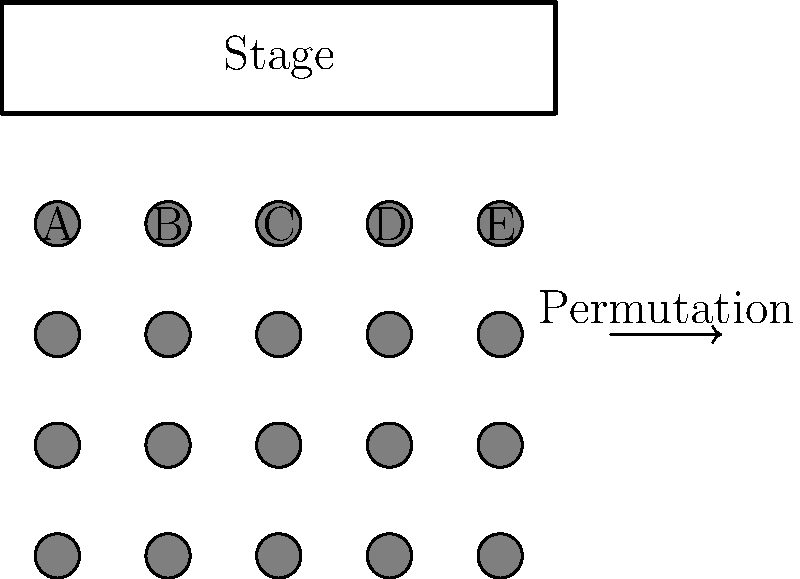In a theater with 5 front-row seats labeled A, B, C, D, and E, how many unique seating arrangements are possible for a group of 5 friends if two of them, Alice and Bob, insist on sitting next to each other? Let's approach this step-by-step:

1) First, consider Alice and Bob as a single unit. This means we now have 4 units to arrange: (Alice-Bob unit), Friend 1, Friend 2, and Friend 3.

2) The number of ways to arrange 4 units is $4! = 4 \times 3 \times 2 \times 1 = 24$.

3) However, for each of these 24 arrangements, Alice and Bob can swap their positions. This doubles our total number of arrangements.

4) Therefore, the total number of unique seating arrangements is:

   $24 \times 2 = 48$

5) We can also think about this using group theory:
   - The symmetric group $S_5$ represents all permutations of 5 elements.
   - The subgroup of permutations where Alice and Bob are adjacent is isomorphic to $S_4 \times S_2$.
   - $|S_4 \times S_2| = |S_4| \times |S_2| = 4! \times 2! = 24 \times 2 = 48$

Thus, there are 48 unique seating arrangements satisfying the given conditions.
Answer: 48 